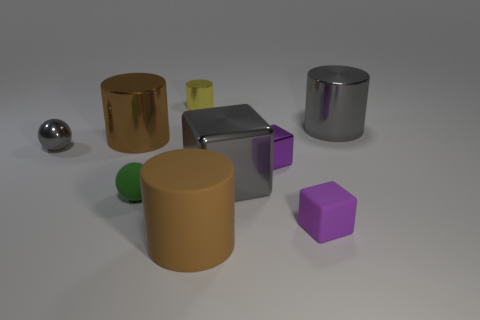How many other objects are there of the same material as the yellow thing? Including the yellow cylinder, there are three objects that appear to be made of a similar matte-finish, solid-colored plastic material. These are the yellow cylinder, the green sphere, and the purple cube. 